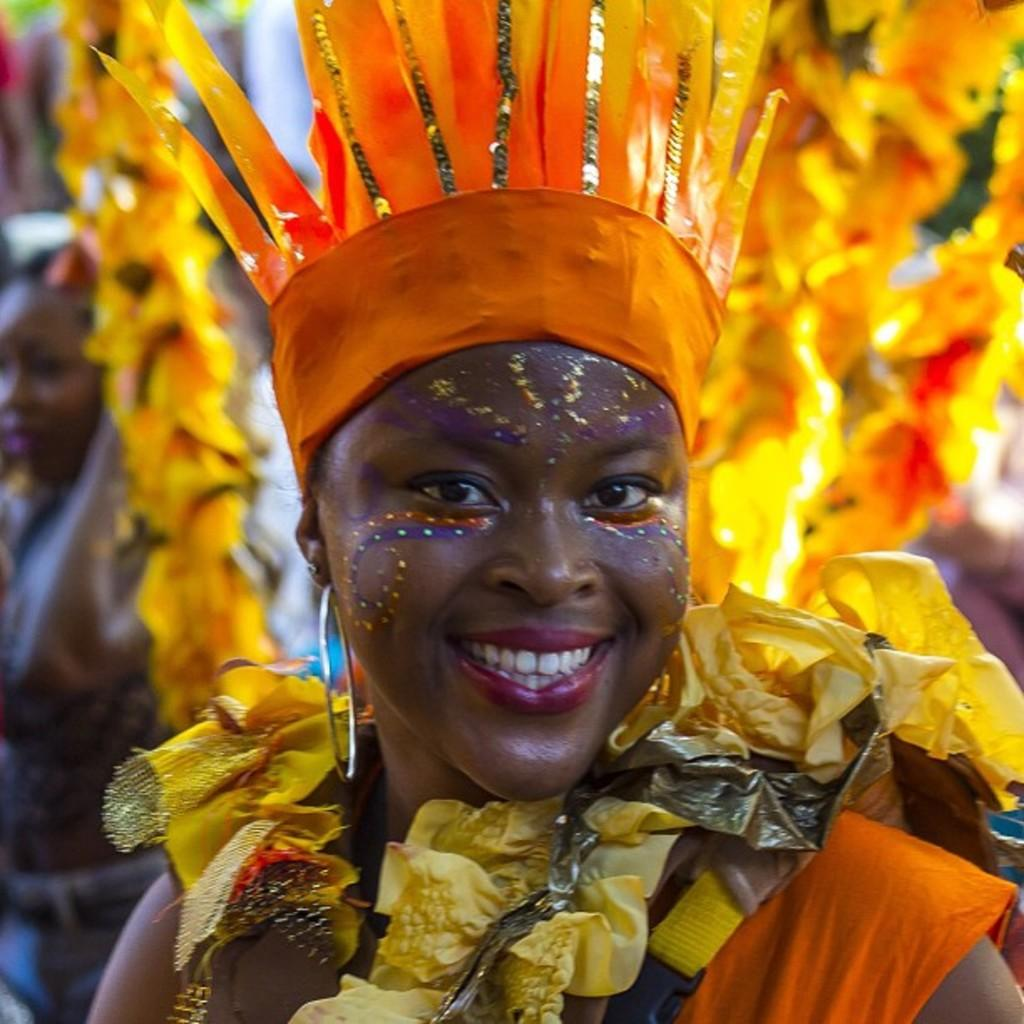What is the main subject of the image? There is a person in the image. What can be observed about the person's attire? The person is wearing clothes. Can you describe the background of the image? The background of the image is blurred. What type of silk is being used to make the person's clothes in the image? There is no mention of silk or any specific fabric in the image; the person is simply wearing clothes. What type of food can be seen in the person's hand in the image? There is no food visible in the person's hand or anywhere else in the image. 